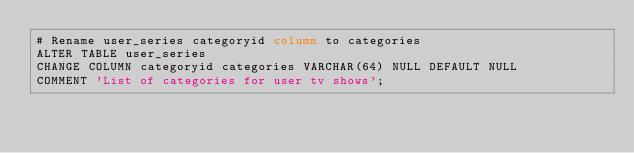Convert code to text. <code><loc_0><loc_0><loc_500><loc_500><_SQL_># Rename user_series categoryid column to categories
ALTER TABLE user_series
CHANGE COLUMN categoryid categories VARCHAR(64) NULL DEFAULT NULL
COMMENT 'List of categories for user tv shows';
</code> 